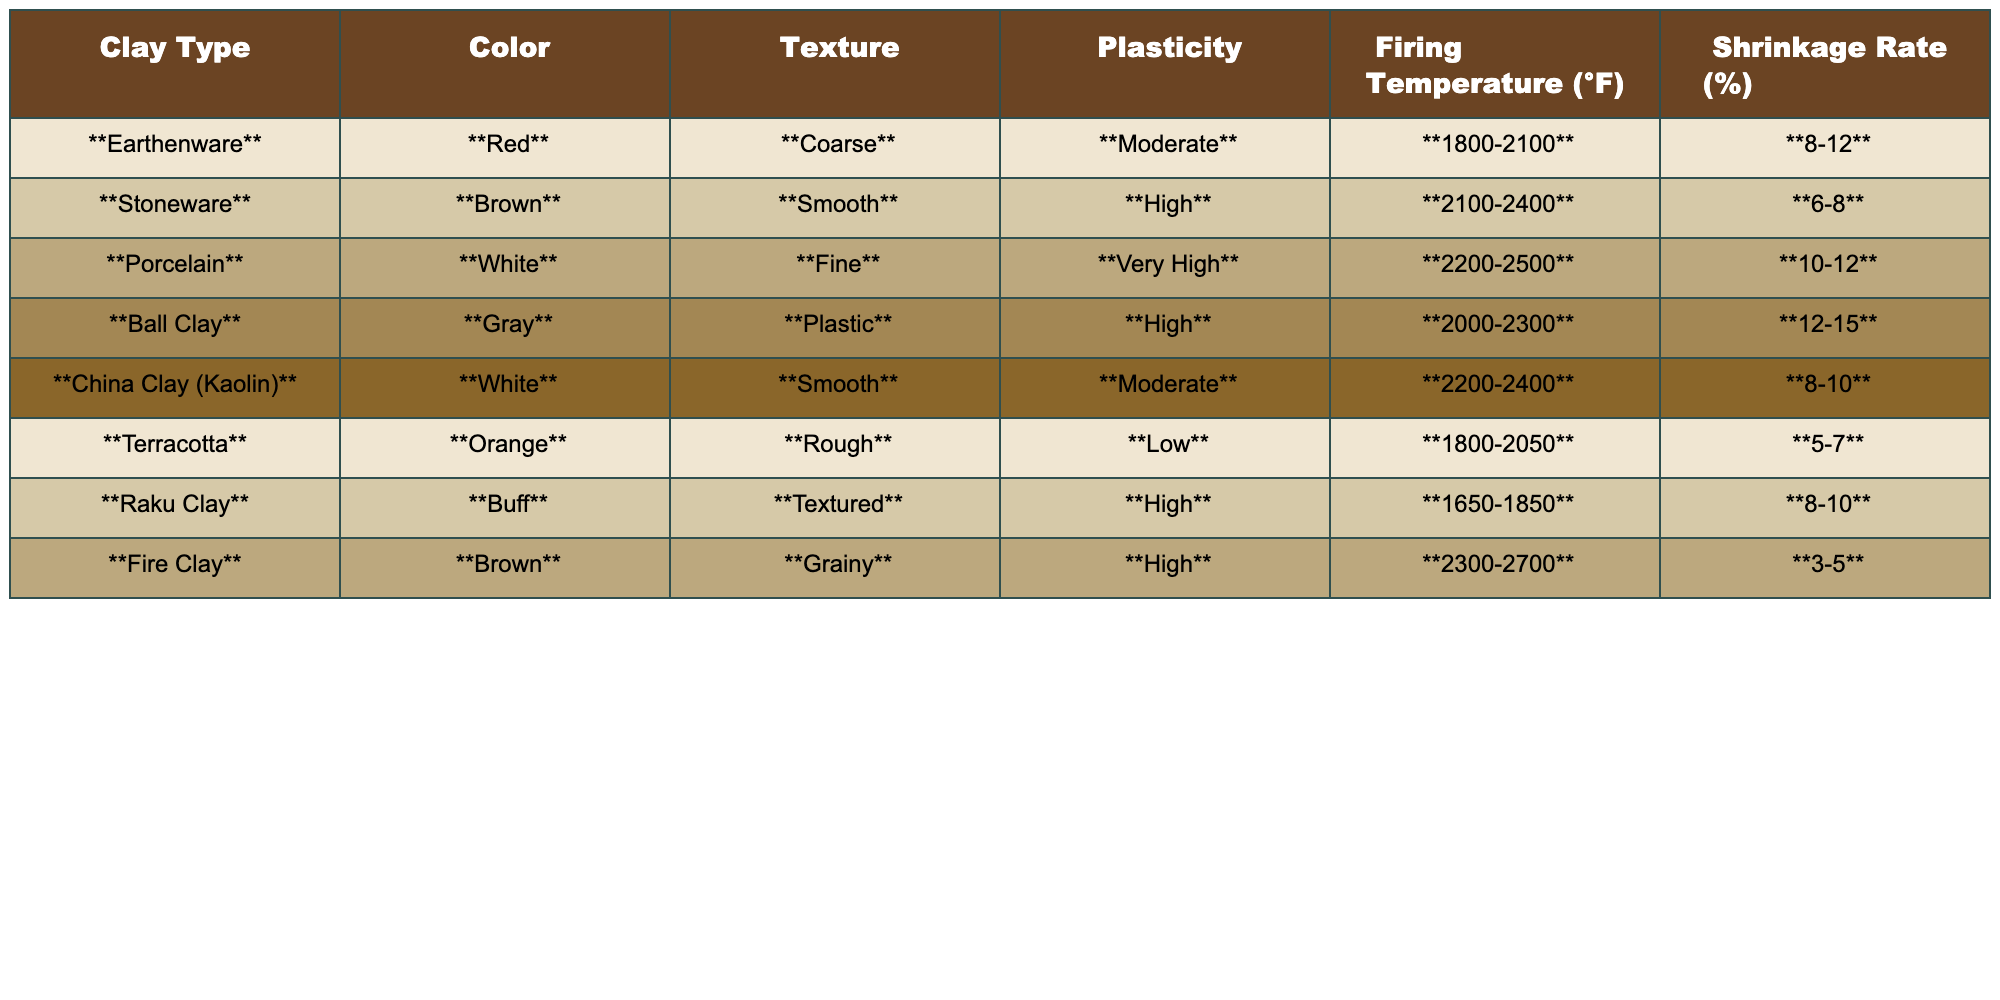What is the firing temperature range for Porcelain? Looking at the table, the firing temperature range for Porcelain is listed directly in the corresponding row, which is 2200-2500 °F.
Answer: 2200-2500 °F Which clay type has the highest plasticity? The table shows that Porcelain has the highest plasticity rating with "Very High" compared to the others that are rated as Low, Moderate, or High.
Answer: Porcelain What is the shrinkage rate for Raku Clay? The shrinkage rate for Raku Clay is found directly in its row, which lists the value as 8-10%.
Answer: 8-10% Which clay type has a reddish color? By checking the Color column, the clay type that has a reddish color is Earthenware, which is clearly labeled as Red.
Answer: Earthenware If you compare Stoneware and Fire Clay, which has a lower firing temperature range? Analyzing the firing temperature ranges, Stoneware (2100-2400 °F) has a lower minimum and maximum range than Fire Clay (2300-2700 °F). Therefore, Stoneware has a lower firing temperature range.
Answer: Stoneware Is the texture of Ball Clay considered coarse? The table indicates that the texture of Ball Clay is categorized as "Plastic," which is not the same as Coarse. Therefore, the statement is false.
Answer: No What is the average firing temperature range for all clay types? To find the average, calculate the midpoints for each firing temperature range: Earthenware (1950), Stoneware (2250), Porcelain (2350), Ball Clay (2150), China Clay (Kaolin) (2300), Terracotta (1925), Raku Clay (1750), Fire Clay (2500). The average is (1950 + 2250 + 2350 + 2150 + 2300 + 1925 + 1750 + 2500) / 8 = 2206.25 °F. The average firing temperature is approximately 2206 °F.
Answer: 2206 °F Which clay type has the lowest shrinkage rate? Looking at the shrinkage rates, Terracotta shows the lowest percentage of 5-7% when compared to other clay types.
Answer: Terracotta Can you find a clay type that has both high plasticity and a low shrinkage rate? Reviewing the table, Ball Clay shows high plasticity and has a higher shrinkage rate (12-15%), while Terracotta has low plasticity and the lowest shrinkage rate; hence, neither clay type meets the criteria together.
Answer: No What can you conclude about the texture of the clay types concerning their plasticity? By reviewing the data, it appears that higher plasticity types like Ball Clay and Porcelain have smoother or finer textures, while types with lower plasticity like Terracotta have rough textures. There seems to be a trend where higher plasticity aligns with finer textures.
Answer: Higher plasticity often correlates with finer textures 